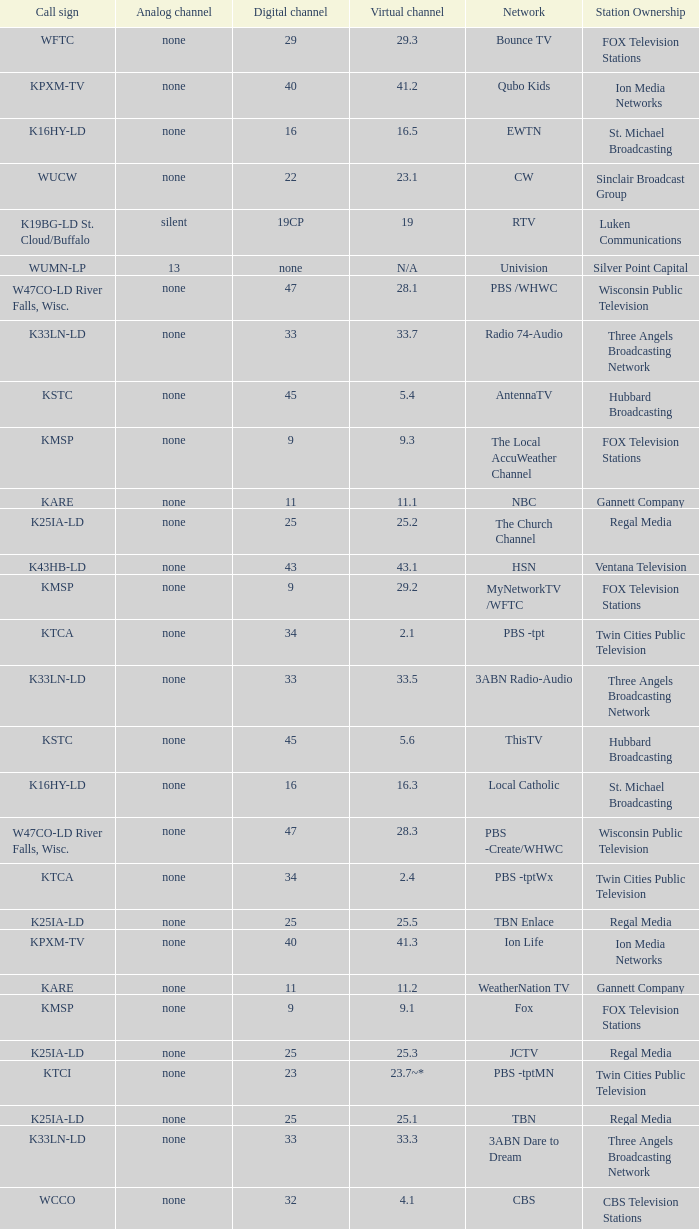Network of nbc is what digital channel? 11.0. 